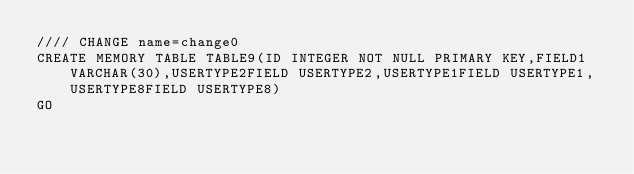Convert code to text. <code><loc_0><loc_0><loc_500><loc_500><_SQL_>//// CHANGE name=change0
CREATE MEMORY TABLE TABLE9(ID INTEGER NOT NULL PRIMARY KEY,FIELD1 VARCHAR(30),USERTYPE2FIELD USERTYPE2,USERTYPE1FIELD USERTYPE1,USERTYPE8FIELD USERTYPE8)
GO
</code> 